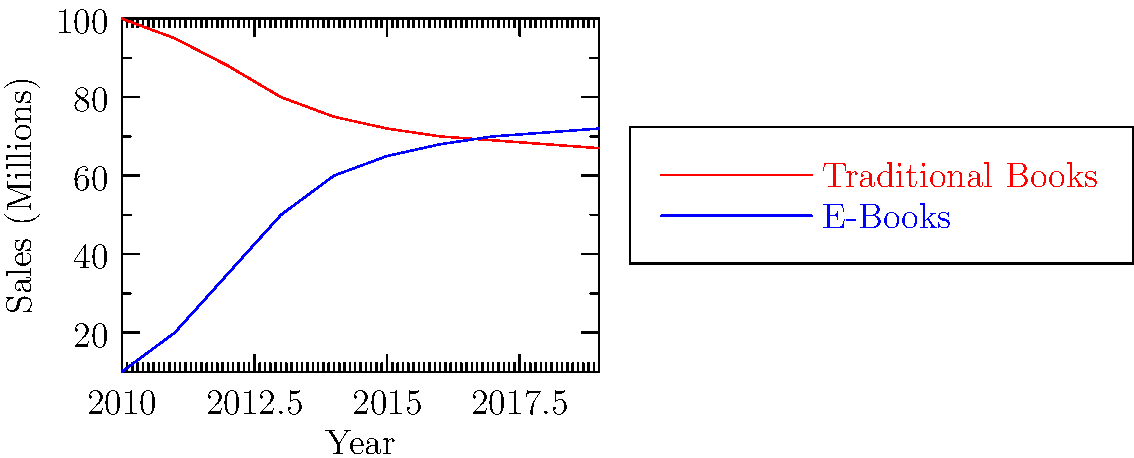Analyze the line graph depicting traditional book and e-book sales in suburban areas from 2010 to 2019. In which year did e-book sales surpass traditional book sales, and what might this trend suggest about the future of book consumption in suburban communities? To answer this question, we need to examine the graph carefully and follow these steps:

1. Observe the two lines: red for traditional books and blue for e-books.
2. Look for the point where the blue line (e-books) crosses above the red line (traditional books).
3. This intersection occurs between 2015 and 2016.
4. To be more precise, we can estimate the sales figures for 2015 and 2016:
   - 2015: Traditional ≈ 72 million, E-books ≈ 65 million
   - 2016: Traditional ≈ 70 million, E-books ≈ 68 million
5. The lines cross between these two years, so we can conclude that e-book sales surpassed traditional book sales in 2016.

Regarding the future trend:
1. Notice that the traditional book sales line is gradually decreasing but seems to be stabilizing around 67-68 million.
2. The e-book sales line is increasing but its growth rate is slowing down.
3. By 2019, both lines are very close, with e-books slightly higher.

This trend suggests that in suburban communities:
1. E-books have gained significant popularity, overtaking traditional books.
2. However, traditional books are maintaining a substantial market share.
3. The market might be reaching an equilibrium where both formats coexist, each serving different reader preferences or purposes.
4. Future innovations in e-reader technology or changes in reading habits could further impact this balance.
Answer: E-book sales surpassed traditional book sales in 2016, suggesting a future of coexistence between both formats in suburban communities, with potential for further shifts based on technological advancements and changing reader preferences. 